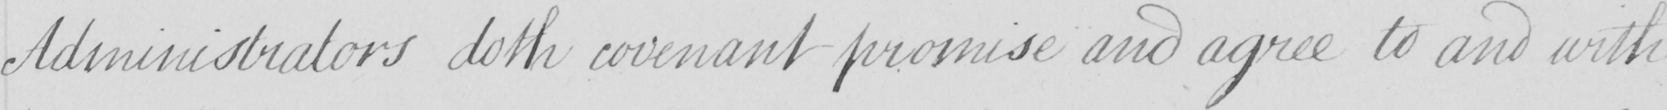Please provide the text content of this handwritten line. Administrators doth covenant promise and agree to and with 